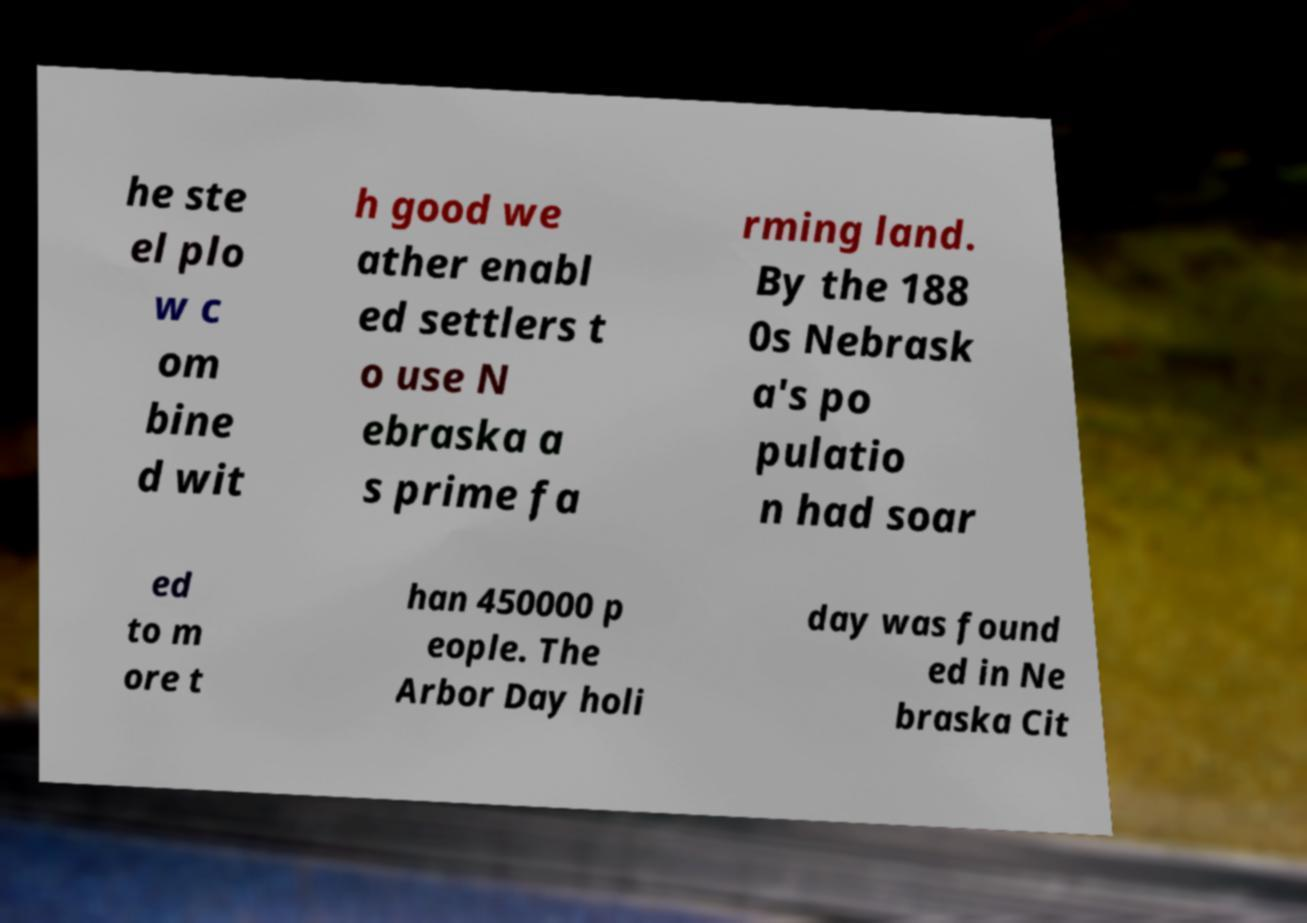Can you read and provide the text displayed in the image?This photo seems to have some interesting text. Can you extract and type it out for me? he ste el plo w c om bine d wit h good we ather enabl ed settlers t o use N ebraska a s prime fa rming land. By the 188 0s Nebrask a's po pulatio n had soar ed to m ore t han 450000 p eople. The Arbor Day holi day was found ed in Ne braska Cit 